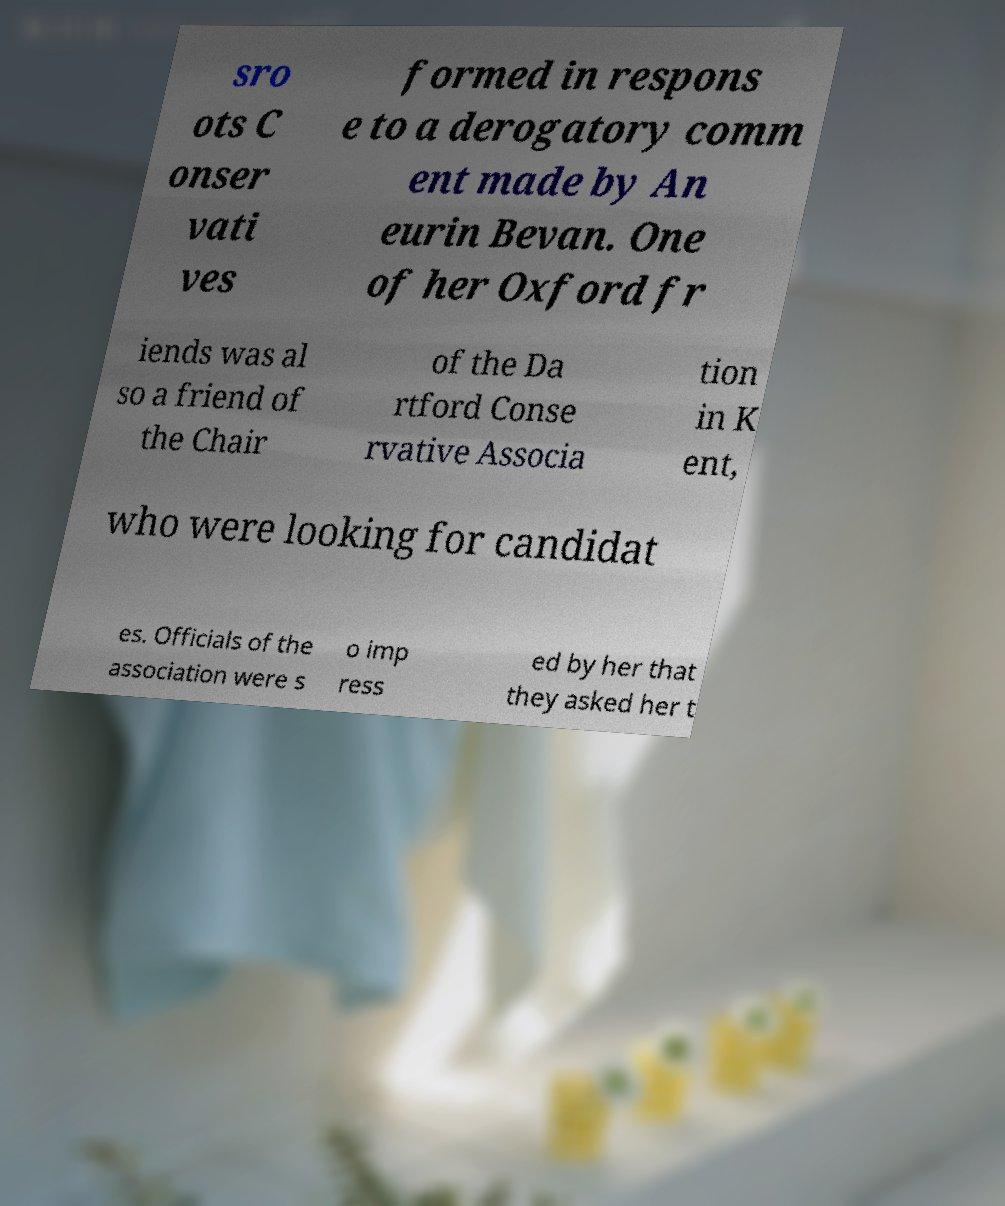Please identify and transcribe the text found in this image. sro ots C onser vati ves formed in respons e to a derogatory comm ent made by An eurin Bevan. One of her Oxford fr iends was al so a friend of the Chair of the Da rtford Conse rvative Associa tion in K ent, who were looking for candidat es. Officials of the association were s o imp ress ed by her that they asked her t 